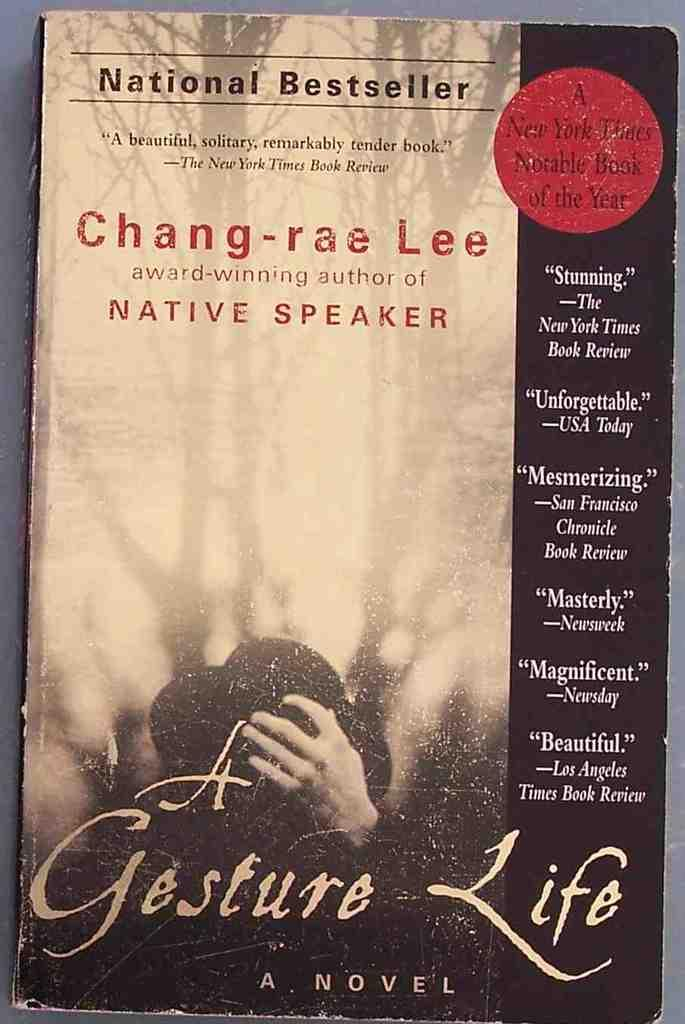<image>
Present a compact description of the photo's key features. The book cover the the National Bestseller "A Gesture Life" by Chang-rae Lee is shown. 